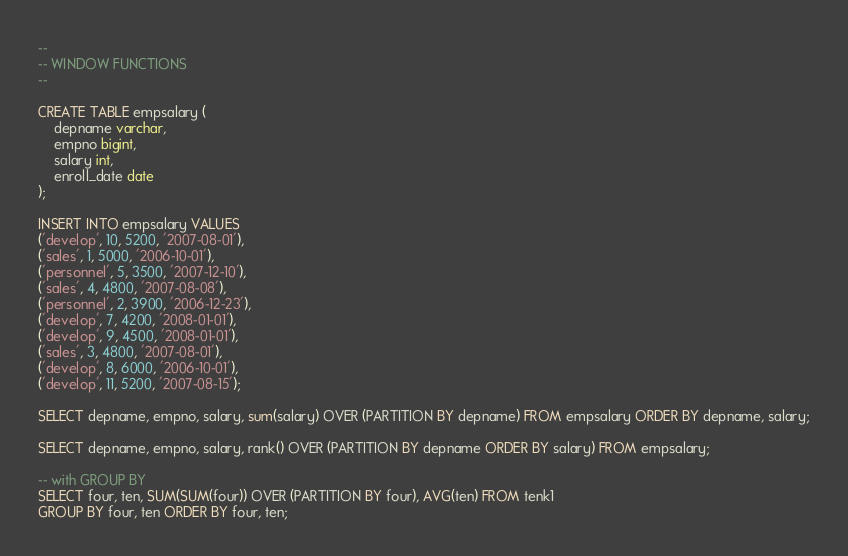Convert code to text. <code><loc_0><loc_0><loc_500><loc_500><_SQL_>--
-- WINDOW FUNCTIONS
--

CREATE TABLE empsalary (
    depname varchar,
    empno bigint,
    salary int,
    enroll_date date
);

INSERT INTO empsalary VALUES
('develop', 10, 5200, '2007-08-01'),
('sales', 1, 5000, '2006-10-01'),
('personnel', 5, 3500, '2007-12-10'),
('sales', 4, 4800, '2007-08-08'),
('personnel', 2, 3900, '2006-12-23'),
('develop', 7, 4200, '2008-01-01'),
('develop', 9, 4500, '2008-01-01'),
('sales', 3, 4800, '2007-08-01'),
('develop', 8, 6000, '2006-10-01'),
('develop', 11, 5200, '2007-08-15');

SELECT depname, empno, salary, sum(salary) OVER (PARTITION BY depname) FROM empsalary ORDER BY depname, salary;

SELECT depname, empno, salary, rank() OVER (PARTITION BY depname ORDER BY salary) FROM empsalary;

-- with GROUP BY
SELECT four, ten, SUM(SUM(four)) OVER (PARTITION BY four), AVG(ten) FROM tenk1
GROUP BY four, ten ORDER BY four, ten;
</code> 